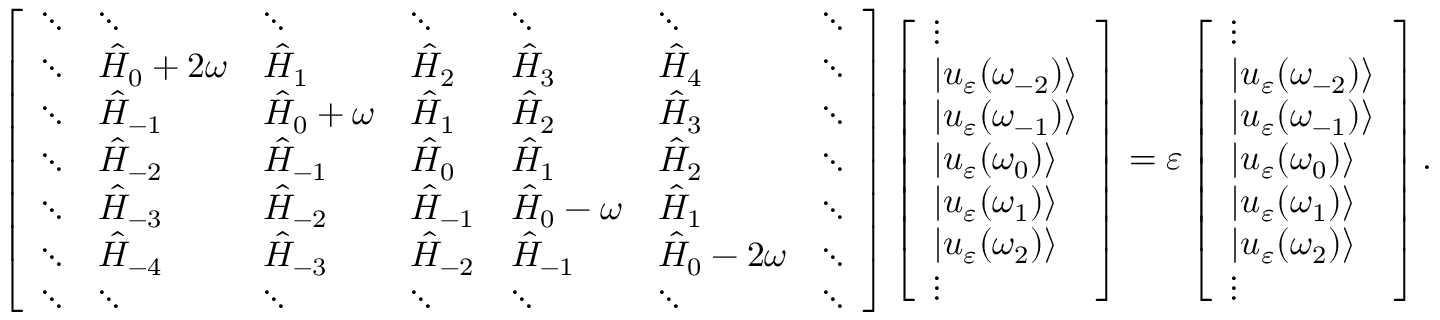Convert formula to latex. <formula><loc_0><loc_0><loc_500><loc_500>\left [ \begin{array} { l l l l l l l } { \ddots } & { \ddots } & { \ddots } & { \ddots } & { \ddots } & { \ddots } & { \ddots } \\ { \ddots } & { \hat { H } _ { 0 } + 2 \omega } & { \hat { H } _ { 1 } } & { \hat { H } _ { 2 } } & { \hat { H } _ { 3 } } & { \hat { H } _ { 4 } } & { \ddots } \\ { \ddots } & { \hat { H } _ { - 1 } } & { \hat { H } _ { 0 } + \omega } & { \hat { H } _ { 1 } } & { \hat { H } _ { 2 } } & { \hat { H } _ { 3 } } & { \ddots } \\ { \ddots } & { \hat { H } _ { - 2 } } & { \hat { H } _ { - 1 } } & { \hat { H } _ { 0 } } & { \hat { H } _ { 1 } } & { \hat { H } _ { 2 } } & { \ddots } \\ { \ddots } & { \hat { H } _ { - 3 } } & { \hat { H } _ { - 2 } } & { \hat { H } _ { - 1 } } & { \hat { H } _ { 0 } - \omega } & { \hat { H } _ { 1 } } & { \ddots } \\ { \ddots } & { \hat { H } _ { - 4 } } & { \hat { H } _ { - 3 } } & { \hat { H } _ { - 2 } } & { \hat { H } _ { - 1 } } & { \hat { H } _ { 0 } - 2 \omega } & { \ddots } \\ { \ddots } & { \ddots } & { \ddots } & { \ddots } & { \ddots } & { \ddots } & { \ddots } \end{array} \right ] \left [ \begin{array} { l } { \vdots } \\ { | u _ { \varepsilon } ( \omega _ { - 2 } ) \rangle } \\ { | u _ { \varepsilon } ( \omega _ { - 1 } ) \rangle } \\ { | u _ { \varepsilon } ( \omega _ { 0 } ) \rangle } \\ { | u _ { \varepsilon } ( \omega _ { 1 } ) \rangle } \\ { | u _ { \varepsilon } ( \omega _ { 2 } ) \rangle } \\ { \vdots } \end{array} \right ] = \varepsilon \left [ \begin{array} { l } { \vdots } \\ { | u _ { \varepsilon } ( \omega _ { - 2 } ) \rangle } \\ { | u _ { \varepsilon } ( \omega _ { - 1 } ) \rangle } \\ { | u _ { \varepsilon } ( \omega _ { 0 } ) \rangle } \\ { | u _ { \varepsilon } ( \omega _ { 1 } ) \rangle } \\ { | u _ { \varepsilon } ( \omega _ { 2 } ) \rangle } \\ { \vdots } \end{array} \right ] .</formula> 